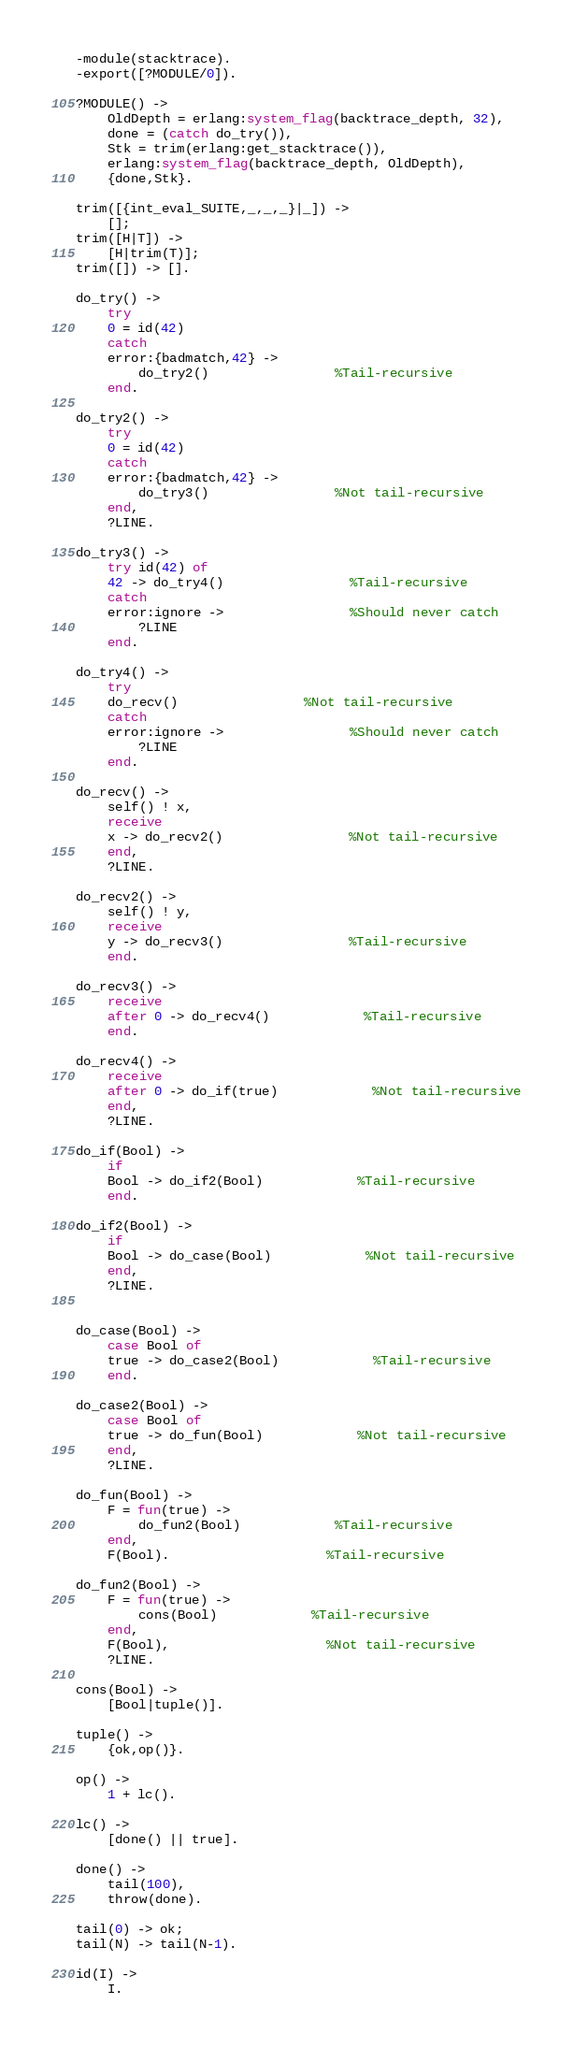Convert code to text. <code><loc_0><loc_0><loc_500><loc_500><_Erlang_>-module(stacktrace).
-export([?MODULE/0]).

?MODULE() ->
    OldDepth = erlang:system_flag(backtrace_depth, 32),
    done = (catch do_try()),
    Stk = trim(erlang:get_stacktrace()),
    erlang:system_flag(backtrace_depth, OldDepth),
    {done,Stk}.

trim([{int_eval_SUITE,_,_,_}|_]) ->
    [];
trim([H|T]) ->
    [H|trim(T)];
trim([]) -> [].

do_try() ->
    try
	0 = id(42)
    catch
	error:{badmatch,42} ->
	    do_try2()				%Tail-recursive
    end.

do_try2() ->
    try
	0 = id(42)
    catch
	error:{badmatch,42} ->
	    do_try3()				%Not tail-recursive
    end,
    ?LINE.

do_try3() ->
    try id(42) of
	42 -> do_try4()				%Tail-recursive
    catch
	error:ignore ->				%Should never catch
	    ?LINE
    end.

do_try4() ->
    try
	do_recv()				%Not tail-recursive
    catch
	error:ignore ->				%Should never catch
	    ?LINE
    end.

do_recv() ->
    self() ! x,
    receive
	x -> do_recv2()				%Not tail-recursive
    end,
    ?LINE.

do_recv2() ->
    self() ! y,
    receive
	y -> do_recv3()				%Tail-recursive
    end.

do_recv3() ->
    receive
	after 0 -> do_recv4()			%Tail-recursive
    end.

do_recv4() ->
    receive
	after 0 -> do_if(true)			%Not tail-recursive
    end,
    ?LINE.

do_if(Bool) ->
    if
	Bool -> do_if2(Bool)			%Tail-recursive
    end.

do_if2(Bool) ->
    if
	Bool -> do_case(Bool)			%Not tail-recursive
    end,
    ?LINE.


do_case(Bool) ->
    case Bool of
	true -> do_case2(Bool)			%Tail-recursive
    end.

do_case2(Bool) ->
    case Bool of
	true -> do_fun(Bool)			%Not tail-recursive
    end,
    ?LINE.

do_fun(Bool) ->
    F = fun(true) ->
		do_fun2(Bool)			%Tail-recursive
	end,
    F(Bool).					%Tail-recursive

do_fun2(Bool) ->
    F = fun(true) ->
		cons(Bool)			%Tail-recursive
	end,
    F(Bool),					%Not tail-recursive
    ?LINE.

cons(Bool) ->
    [Bool|tuple()].

tuple() ->
    {ok,op()}.

op() ->
    1 + lc().

lc() ->
    [done() || true].

done() ->
    tail(100),
    throw(done).

tail(0) -> ok;
tail(N) -> tail(N-1).

id(I) ->
    I.
</code> 